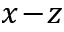Convert formula to latex. <formula><loc_0><loc_0><loc_500><loc_500>x \, - \, z</formula> 